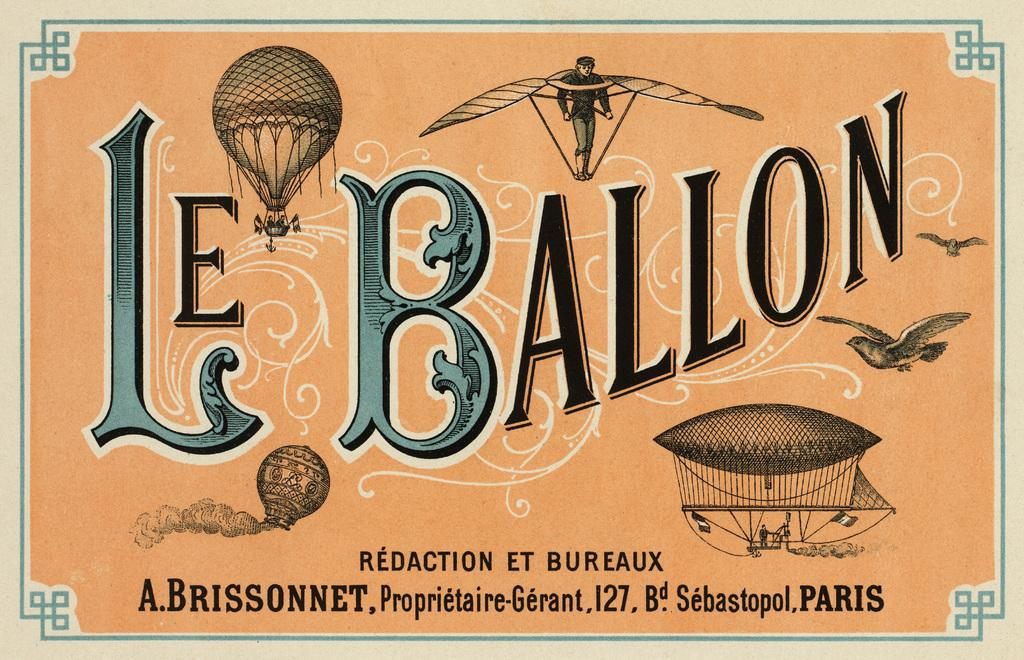<image>
Create a compact narrative representing the image presented. A vintage looking poster that says Le Baron. 